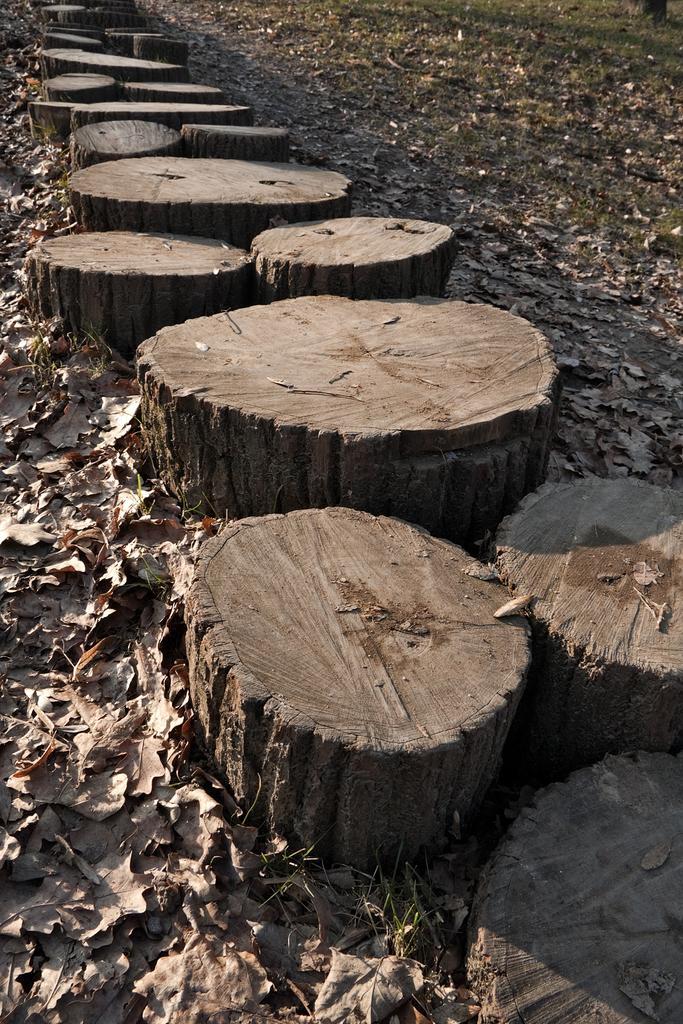Can you describe this image briefly? In this picture we can see wooden objects and dried leaves on the ground. 